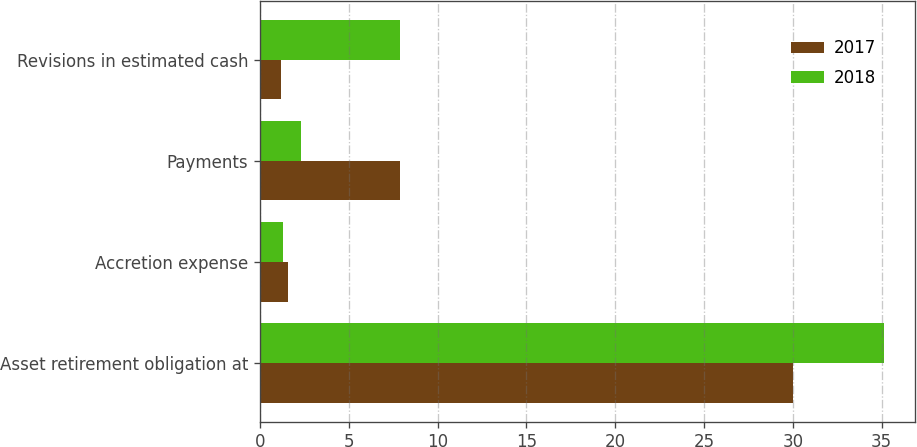Convert chart to OTSL. <chart><loc_0><loc_0><loc_500><loc_500><stacked_bar_chart><ecel><fcel>Asset retirement obligation at<fcel>Accretion expense<fcel>Payments<fcel>Revisions in estimated cash<nl><fcel>2017<fcel>30<fcel>1.6<fcel>7.9<fcel>1.2<nl><fcel>2018<fcel>35.1<fcel>1.3<fcel>2.3<fcel>7.9<nl></chart> 